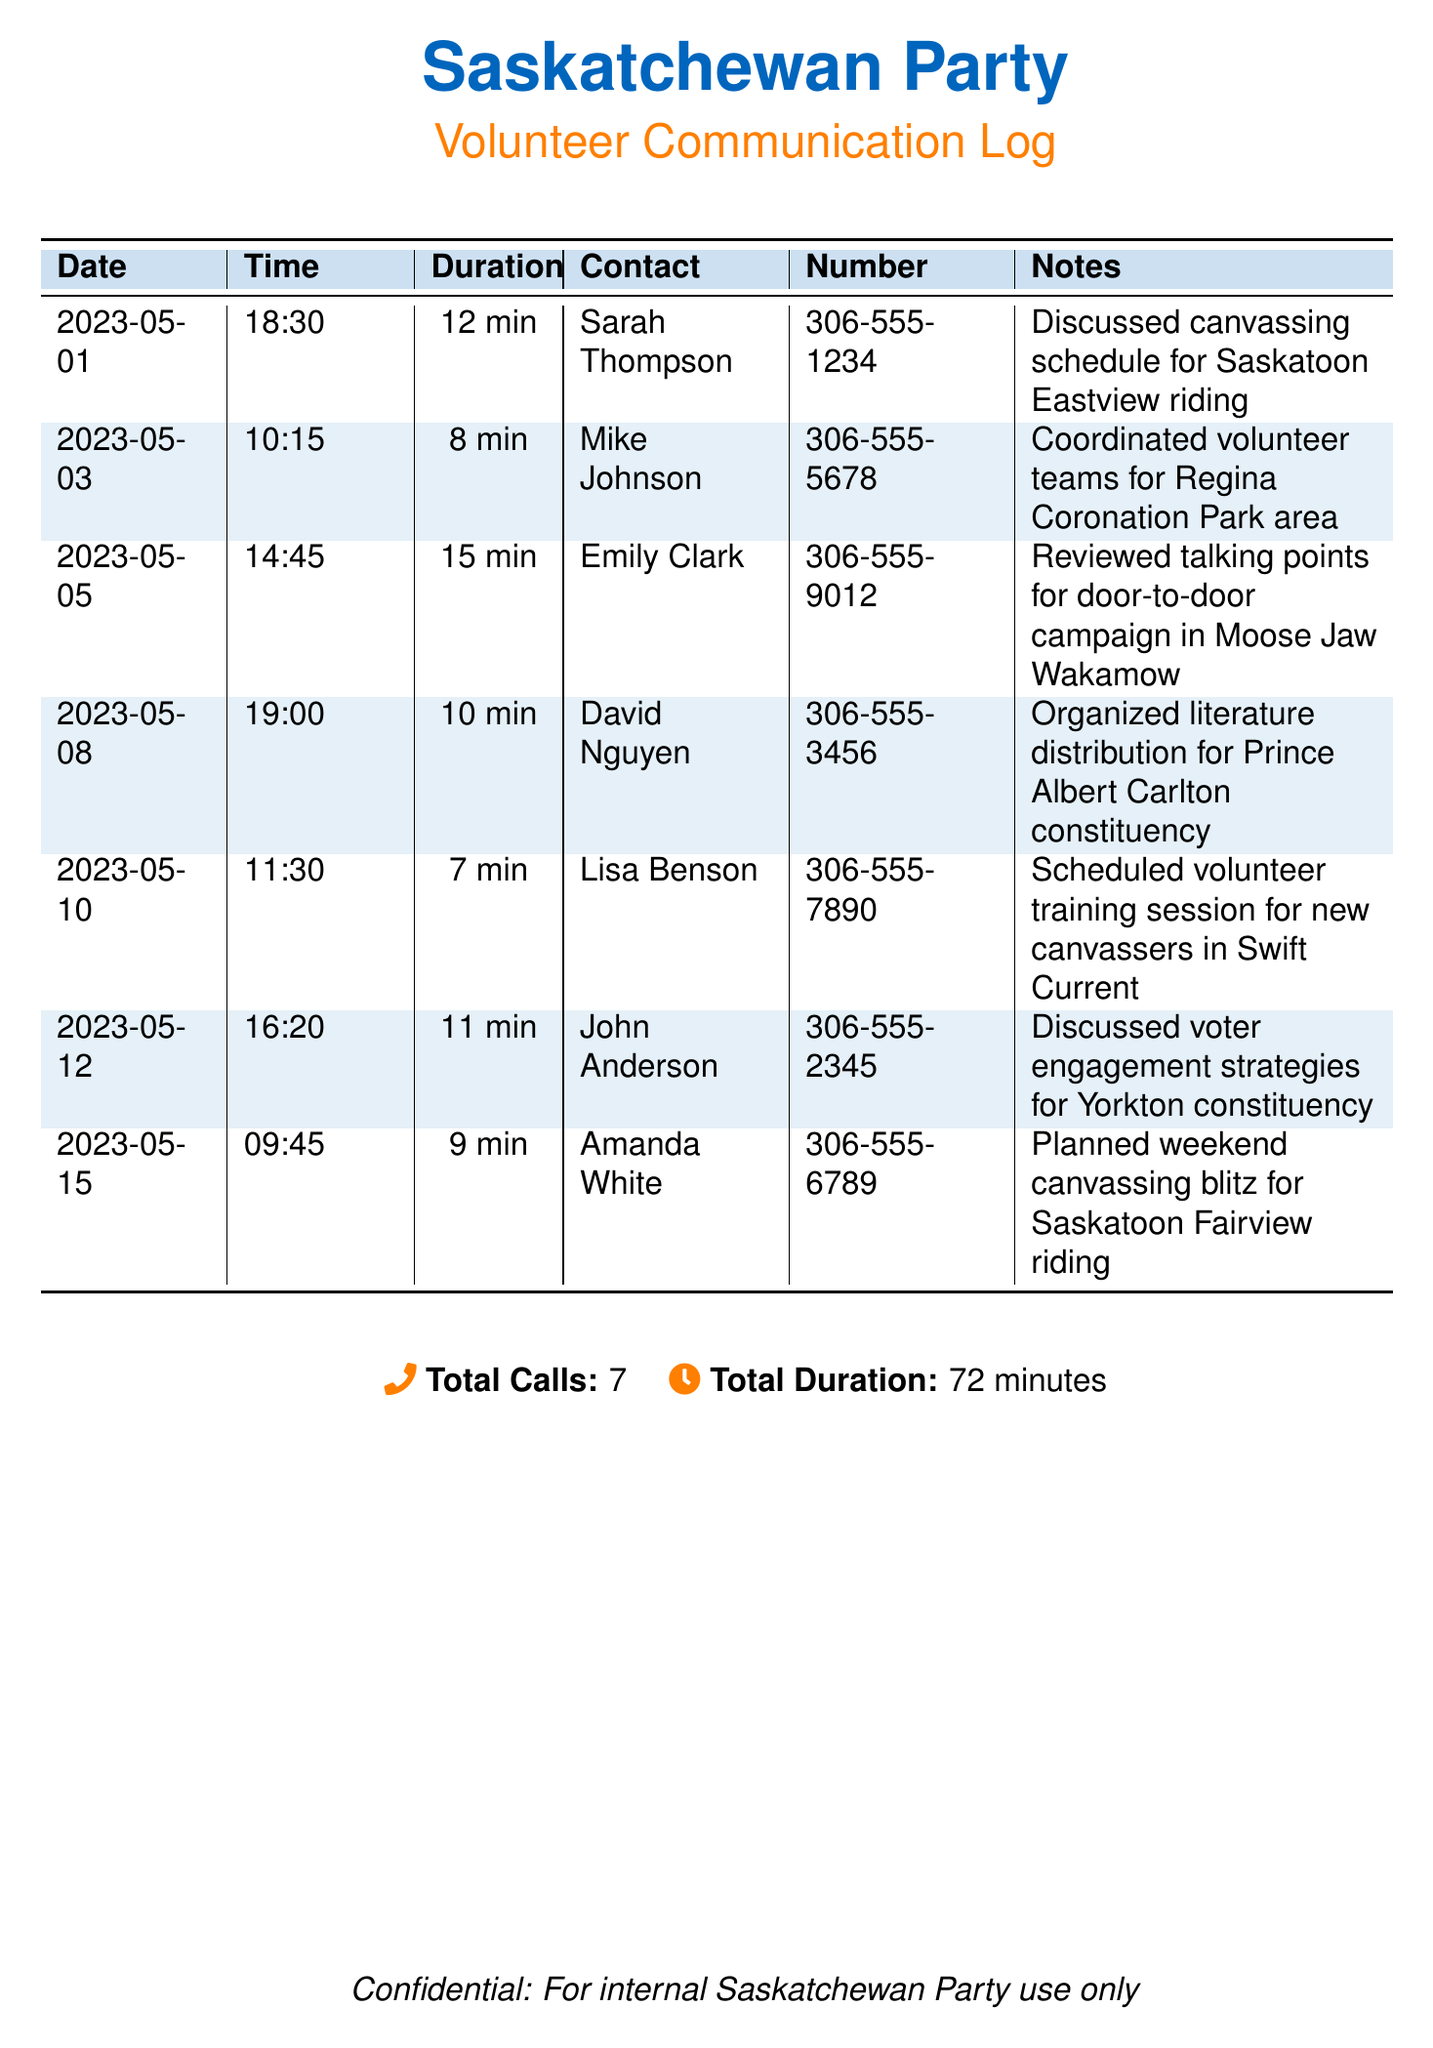What is the total number of calls? The total number of calls is explicitly stated in the document.
Answer: 7 What was discussed with Sarah Thompson? The document notes a specific discussion careening around canvassing scheduling in a given riding.
Answer: Canvassing schedule for Saskatoon Eastview riding Who coordinated volunteer teams for Regina Coronation Park area? The document provides the name of the individual coordinating the teams for that area.
Answer: Mike Johnson What is the duration of the call with Emily Clark? The call duration is stated clearly beside the contact's name.
Answer: 15 min On what date was the volunteer training session scheduled? The document specifies the date linked to the training session.
Answer: 2023-05-10 How many minutes in total were spent on these calls? The total duration of all calls is summarized at the bottom of the document.
Answer: 72 minutes What was planned for the weekend canvassing blitz? This indicates what was discussed during a particular call noted in the document.
Answer: Saskatoon Fairview riding What contact was involved in organizing literature distribution? The document identifies the person responsible for this specific action.
Answer: David Nguyen What was the time of the call with John Anderson? This information is directly available in the records, adjacent to the contact’s name.
Answer: 16:20 